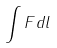<formula> <loc_0><loc_0><loc_500><loc_500>\int F d l</formula> 